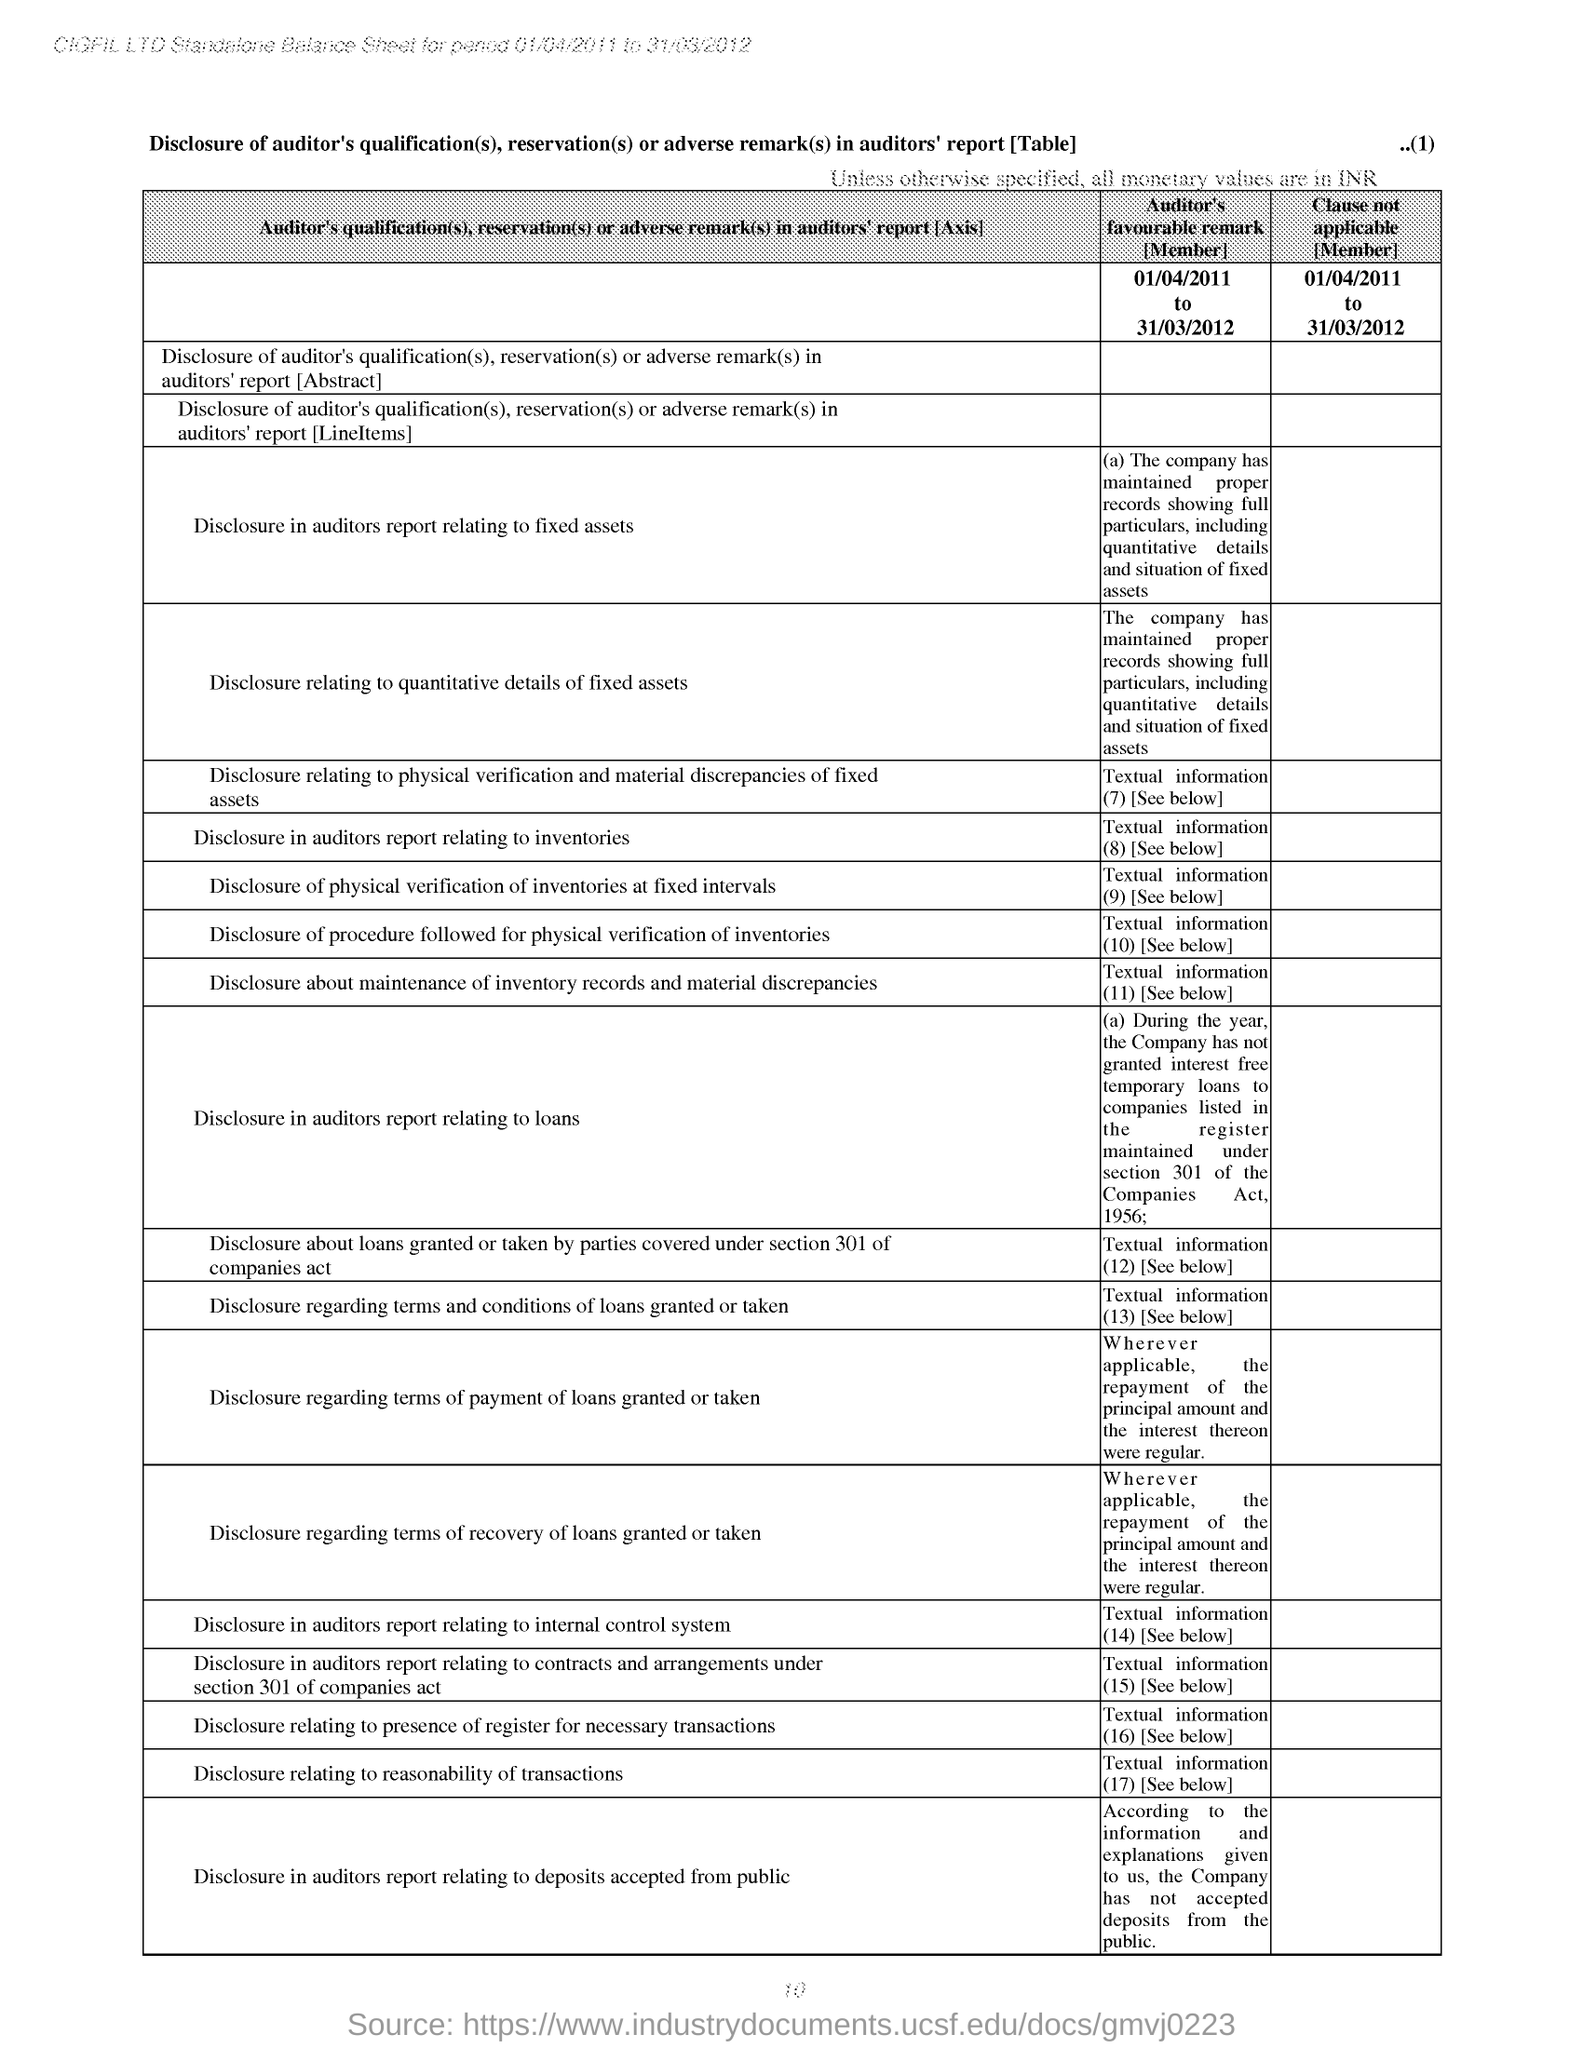Specify some key components in this picture. In the auditor's report, there was a disclosure regarding loans. The auditor mentioned that the disclosure was related to section 301. In its auditor's report pertaining to loans for companies under the Companies Act of 1956, the auditor has made a disclosure. The balance sheet was prepared for the period of 01/04/2011 to 31/03/2012. The page number located at the top right corner of the page is 1. It is generally assumed that all monetary values are valid unless they are explicitly stated to be otherwise, such as with the use of a specific currency symbol or notation. 